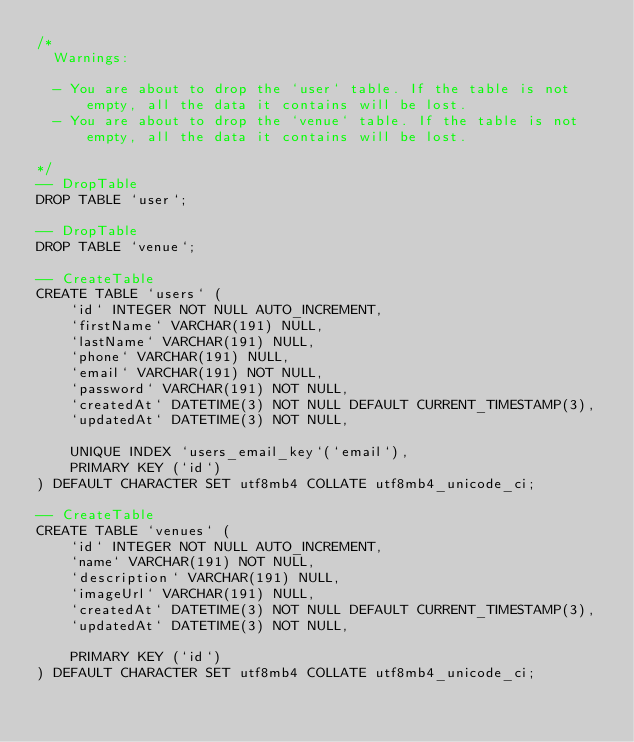Convert code to text. <code><loc_0><loc_0><loc_500><loc_500><_SQL_>/*
  Warnings:

  - You are about to drop the `user` table. If the table is not empty, all the data it contains will be lost.
  - You are about to drop the `venue` table. If the table is not empty, all the data it contains will be lost.

*/
-- DropTable
DROP TABLE `user`;

-- DropTable
DROP TABLE `venue`;

-- CreateTable
CREATE TABLE `users` (
    `id` INTEGER NOT NULL AUTO_INCREMENT,
    `firstName` VARCHAR(191) NULL,
    `lastName` VARCHAR(191) NULL,
    `phone` VARCHAR(191) NULL,
    `email` VARCHAR(191) NOT NULL,
    `password` VARCHAR(191) NOT NULL,
    `createdAt` DATETIME(3) NOT NULL DEFAULT CURRENT_TIMESTAMP(3),
    `updatedAt` DATETIME(3) NOT NULL,

    UNIQUE INDEX `users_email_key`(`email`),
    PRIMARY KEY (`id`)
) DEFAULT CHARACTER SET utf8mb4 COLLATE utf8mb4_unicode_ci;

-- CreateTable
CREATE TABLE `venues` (
    `id` INTEGER NOT NULL AUTO_INCREMENT,
    `name` VARCHAR(191) NOT NULL,
    `description` VARCHAR(191) NULL,
    `imageUrl` VARCHAR(191) NULL,
    `createdAt` DATETIME(3) NOT NULL DEFAULT CURRENT_TIMESTAMP(3),
    `updatedAt` DATETIME(3) NOT NULL,

    PRIMARY KEY (`id`)
) DEFAULT CHARACTER SET utf8mb4 COLLATE utf8mb4_unicode_ci;
</code> 